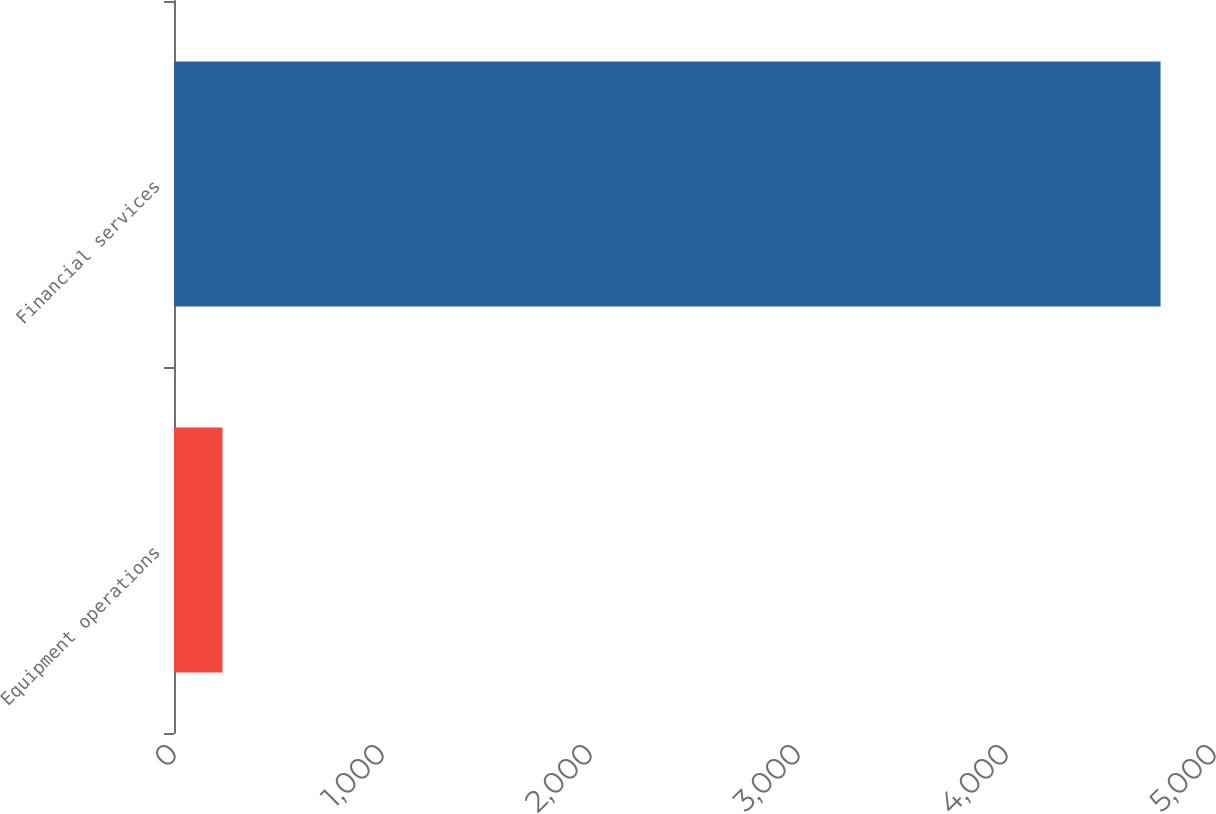<chart> <loc_0><loc_0><loc_500><loc_500><bar_chart><fcel>Equipment operations<fcel>Financial services<nl><fcel>233<fcel>4743<nl></chart> 